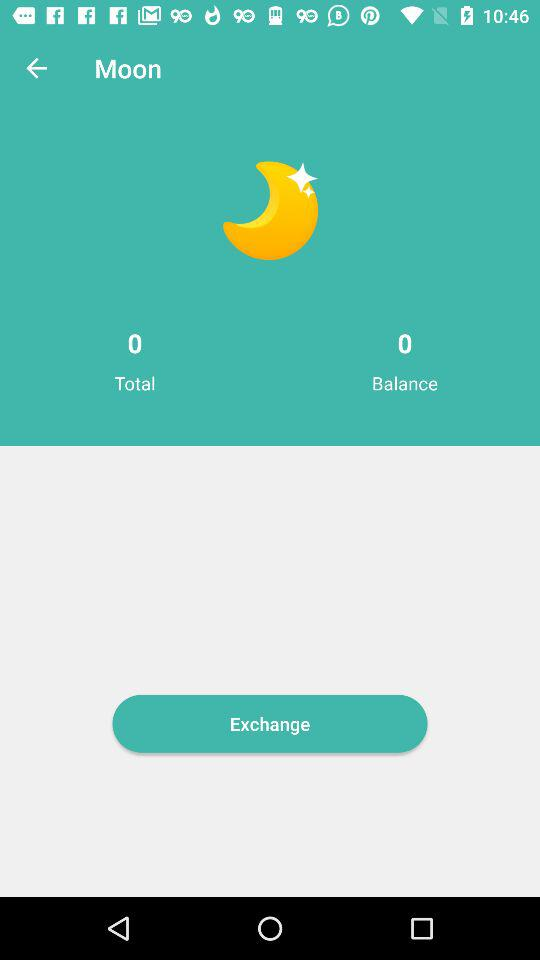What is the total count for "Moon"? The total count is 0. 